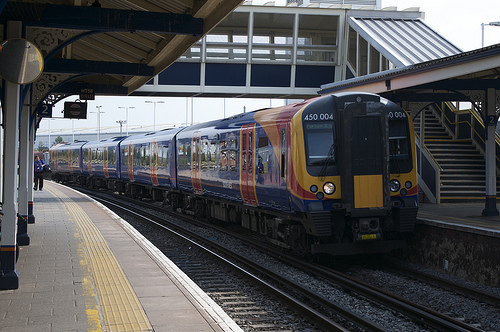Please provide the bounding box coordinate of the region this sentence describes: Train rail. The train rail extends throughout the coordinates [0.24, 0.65, 1.0, 0.82], visually defining the tracks on which trains travel, crucial for the guidance and direction of the train movements. 